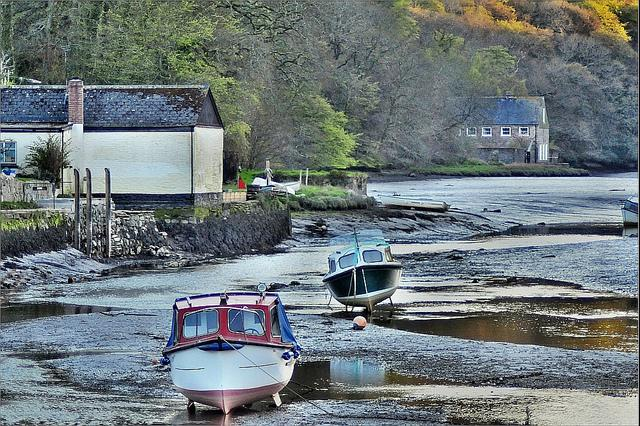What shape is the item on the floor that is in front of the boat that is behind the red boat? Please explain your reasoning. round. The shape is circular. 